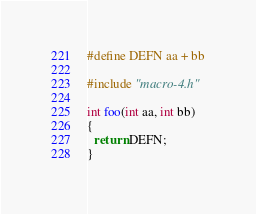<code> <loc_0><loc_0><loc_500><loc_500><_C_>#define DEFN aa + bb

#include "macro-4.h"

int foo(int aa, int bb)
{
  return DEFN;
}
</code> 